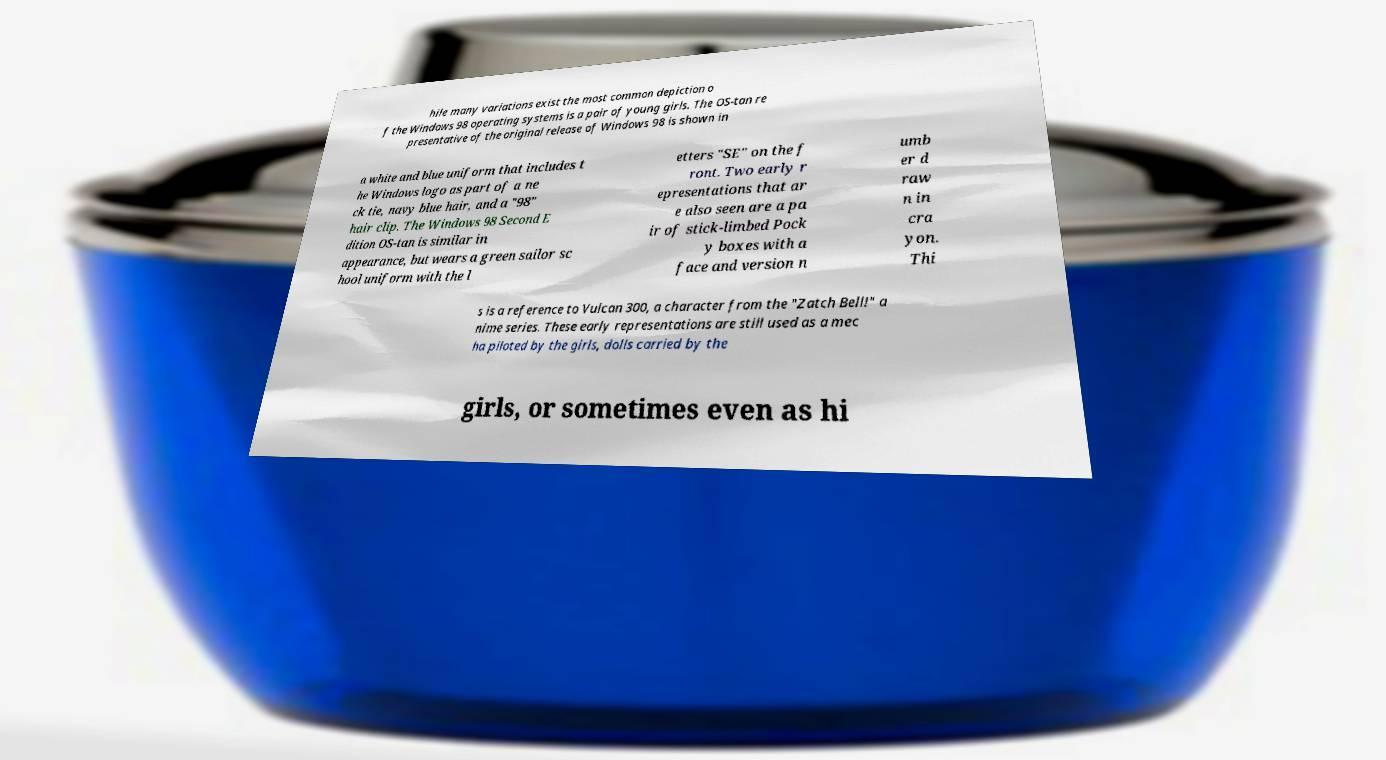Please read and relay the text visible in this image. What does it say? hile many variations exist the most common depiction o f the Windows 98 operating systems is a pair of young girls. The OS-tan re presentative of the original release of Windows 98 is shown in a white and blue uniform that includes t he Windows logo as part of a ne ck tie, navy blue hair, and a "98" hair clip. The Windows 98 Second E dition OS-tan is similar in appearance, but wears a green sailor sc hool uniform with the l etters "SE" on the f ront. Two early r epresentations that ar e also seen are a pa ir of stick-limbed Pock y boxes with a face and version n umb er d raw n in cra yon. Thi s is a reference to Vulcan 300, a character from the "Zatch Bell!" a nime series. These early representations are still used as a mec ha piloted by the girls, dolls carried by the girls, or sometimes even as hi 